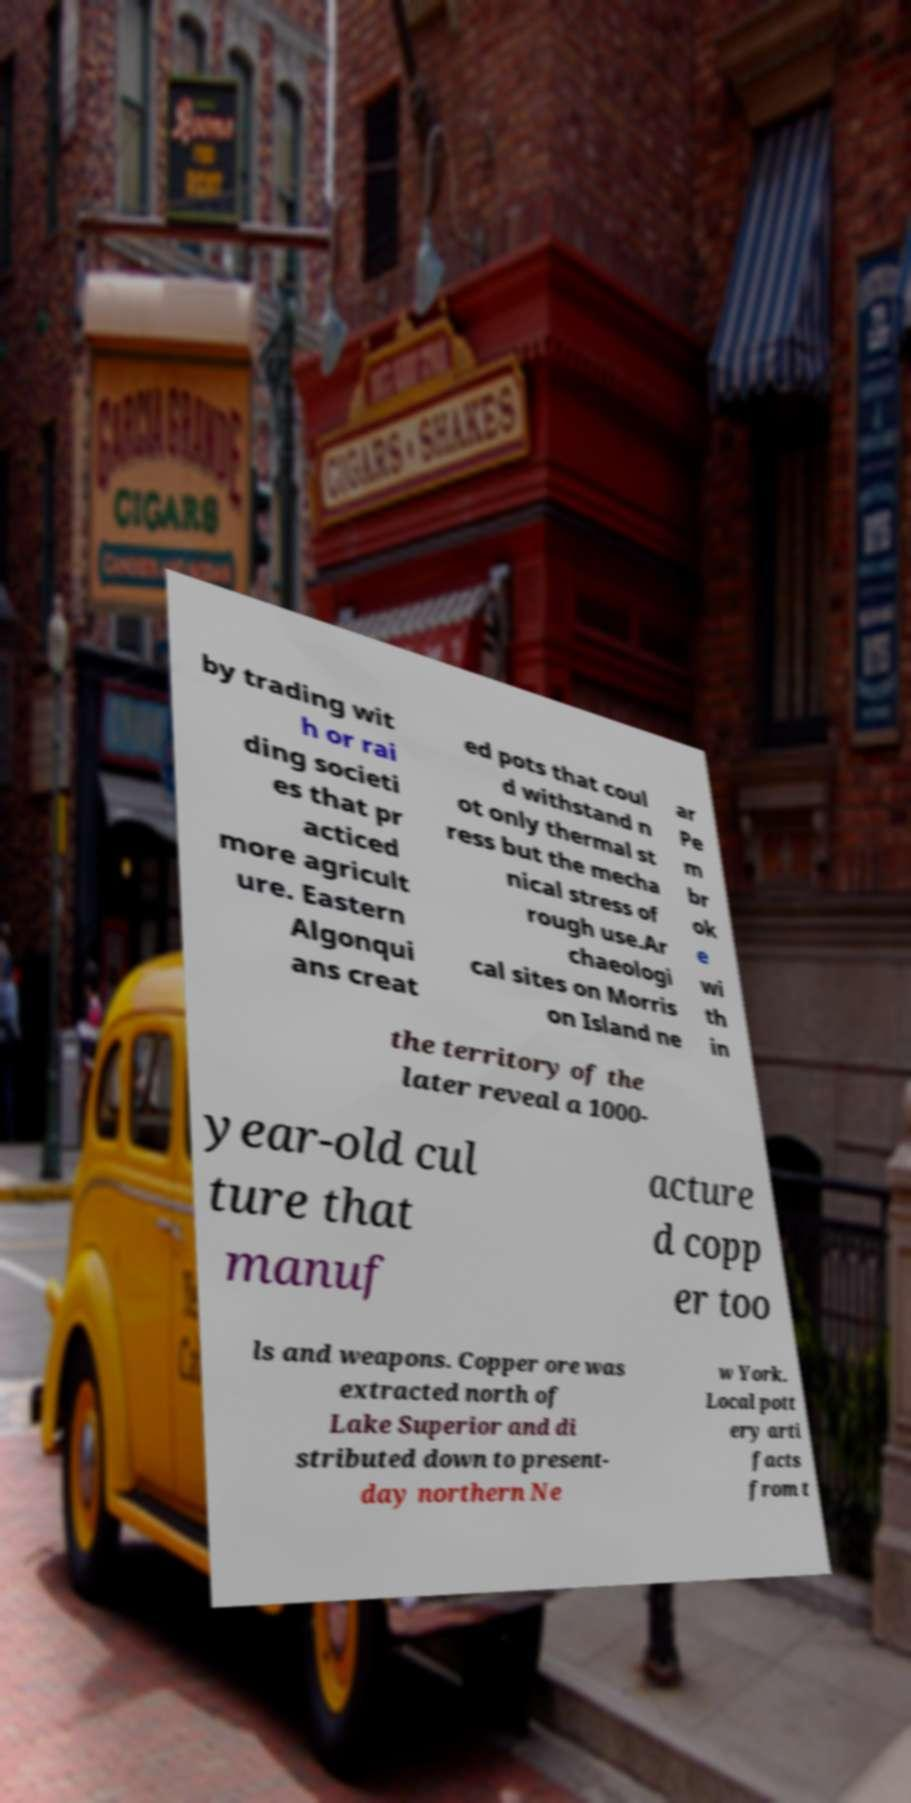Could you extract and type out the text from this image? by trading wit h or rai ding societi es that pr acticed more agricult ure. Eastern Algonqui ans creat ed pots that coul d withstand n ot only thermal st ress but the mecha nical stress of rough use.Ar chaeologi cal sites on Morris on Island ne ar Pe m br ok e wi th in the territory of the later reveal a 1000- year-old cul ture that manuf acture d copp er too ls and weapons. Copper ore was extracted north of Lake Superior and di stributed down to present- day northern Ne w York. Local pott ery arti facts from t 